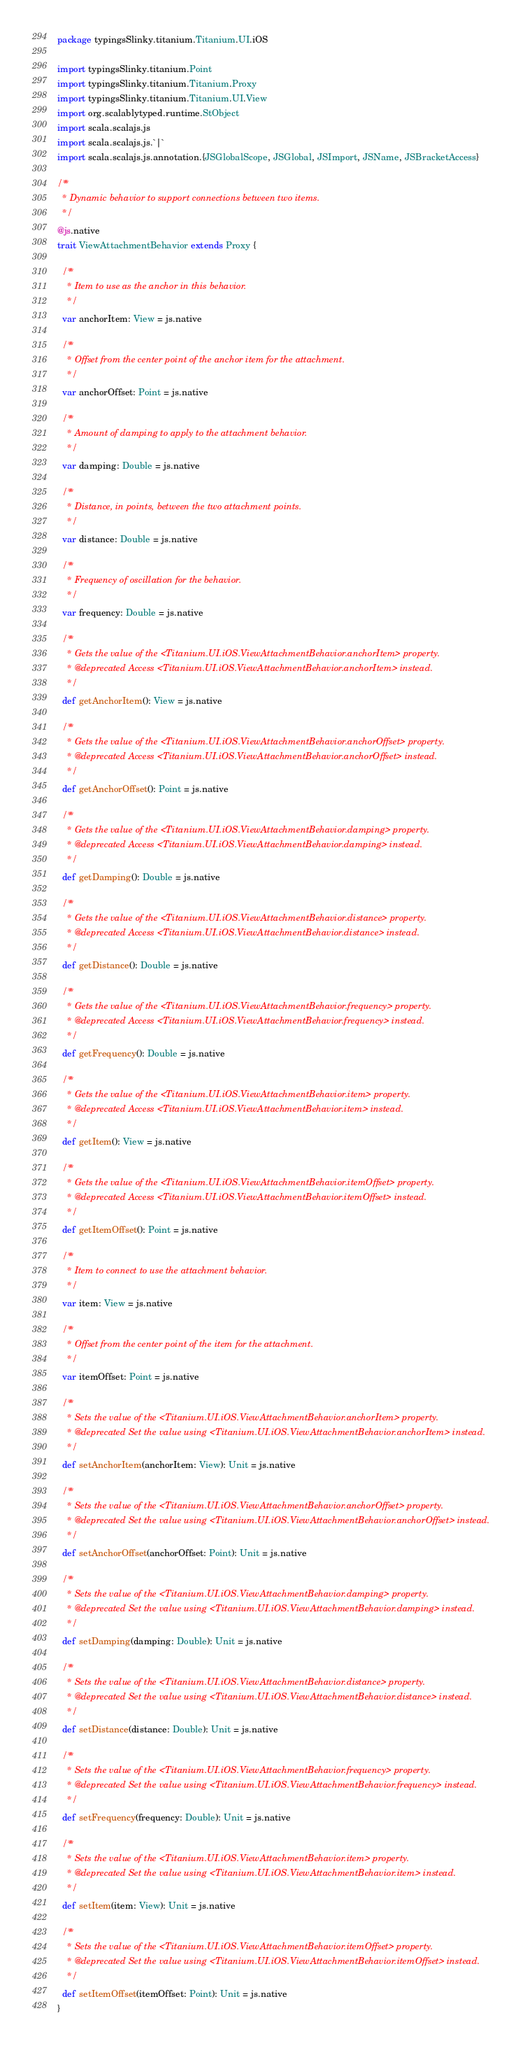<code> <loc_0><loc_0><loc_500><loc_500><_Scala_>package typingsSlinky.titanium.Titanium.UI.iOS

import typingsSlinky.titanium.Point
import typingsSlinky.titanium.Titanium.Proxy
import typingsSlinky.titanium.Titanium.UI.View
import org.scalablytyped.runtime.StObject
import scala.scalajs.js
import scala.scalajs.js.`|`
import scala.scalajs.js.annotation.{JSGlobalScope, JSGlobal, JSImport, JSName, JSBracketAccess}

/**
  * Dynamic behavior to support connections between two items.
  */
@js.native
trait ViewAttachmentBehavior extends Proxy {
  
  /**
    * Item to use as the anchor in this behavior.
    */
  var anchorItem: View = js.native
  
  /**
    * Offset from the center point of the anchor item for the attachment.
    */
  var anchorOffset: Point = js.native
  
  /**
    * Amount of damping to apply to the attachment behavior.
    */
  var damping: Double = js.native
  
  /**
    * Distance, in points, between the two attachment points.
    */
  var distance: Double = js.native
  
  /**
    * Frequency of oscillation for the behavior.
    */
  var frequency: Double = js.native
  
  /**
    * Gets the value of the <Titanium.UI.iOS.ViewAttachmentBehavior.anchorItem> property.
    * @deprecated Access <Titanium.UI.iOS.ViewAttachmentBehavior.anchorItem> instead.
    */
  def getAnchorItem(): View = js.native
  
  /**
    * Gets the value of the <Titanium.UI.iOS.ViewAttachmentBehavior.anchorOffset> property.
    * @deprecated Access <Titanium.UI.iOS.ViewAttachmentBehavior.anchorOffset> instead.
    */
  def getAnchorOffset(): Point = js.native
  
  /**
    * Gets the value of the <Titanium.UI.iOS.ViewAttachmentBehavior.damping> property.
    * @deprecated Access <Titanium.UI.iOS.ViewAttachmentBehavior.damping> instead.
    */
  def getDamping(): Double = js.native
  
  /**
    * Gets the value of the <Titanium.UI.iOS.ViewAttachmentBehavior.distance> property.
    * @deprecated Access <Titanium.UI.iOS.ViewAttachmentBehavior.distance> instead.
    */
  def getDistance(): Double = js.native
  
  /**
    * Gets the value of the <Titanium.UI.iOS.ViewAttachmentBehavior.frequency> property.
    * @deprecated Access <Titanium.UI.iOS.ViewAttachmentBehavior.frequency> instead.
    */
  def getFrequency(): Double = js.native
  
  /**
    * Gets the value of the <Titanium.UI.iOS.ViewAttachmentBehavior.item> property.
    * @deprecated Access <Titanium.UI.iOS.ViewAttachmentBehavior.item> instead.
    */
  def getItem(): View = js.native
  
  /**
    * Gets the value of the <Titanium.UI.iOS.ViewAttachmentBehavior.itemOffset> property.
    * @deprecated Access <Titanium.UI.iOS.ViewAttachmentBehavior.itemOffset> instead.
    */
  def getItemOffset(): Point = js.native
  
  /**
    * Item to connect to use the attachment behavior.
    */
  var item: View = js.native
  
  /**
    * Offset from the center point of the item for the attachment.
    */
  var itemOffset: Point = js.native
  
  /**
    * Sets the value of the <Titanium.UI.iOS.ViewAttachmentBehavior.anchorItem> property.
    * @deprecated Set the value using <Titanium.UI.iOS.ViewAttachmentBehavior.anchorItem> instead.
    */
  def setAnchorItem(anchorItem: View): Unit = js.native
  
  /**
    * Sets the value of the <Titanium.UI.iOS.ViewAttachmentBehavior.anchorOffset> property.
    * @deprecated Set the value using <Titanium.UI.iOS.ViewAttachmentBehavior.anchorOffset> instead.
    */
  def setAnchorOffset(anchorOffset: Point): Unit = js.native
  
  /**
    * Sets the value of the <Titanium.UI.iOS.ViewAttachmentBehavior.damping> property.
    * @deprecated Set the value using <Titanium.UI.iOS.ViewAttachmentBehavior.damping> instead.
    */
  def setDamping(damping: Double): Unit = js.native
  
  /**
    * Sets the value of the <Titanium.UI.iOS.ViewAttachmentBehavior.distance> property.
    * @deprecated Set the value using <Titanium.UI.iOS.ViewAttachmentBehavior.distance> instead.
    */
  def setDistance(distance: Double): Unit = js.native
  
  /**
    * Sets the value of the <Titanium.UI.iOS.ViewAttachmentBehavior.frequency> property.
    * @deprecated Set the value using <Titanium.UI.iOS.ViewAttachmentBehavior.frequency> instead.
    */
  def setFrequency(frequency: Double): Unit = js.native
  
  /**
    * Sets the value of the <Titanium.UI.iOS.ViewAttachmentBehavior.item> property.
    * @deprecated Set the value using <Titanium.UI.iOS.ViewAttachmentBehavior.item> instead.
    */
  def setItem(item: View): Unit = js.native
  
  /**
    * Sets the value of the <Titanium.UI.iOS.ViewAttachmentBehavior.itemOffset> property.
    * @deprecated Set the value using <Titanium.UI.iOS.ViewAttachmentBehavior.itemOffset> instead.
    */
  def setItemOffset(itemOffset: Point): Unit = js.native
}
</code> 